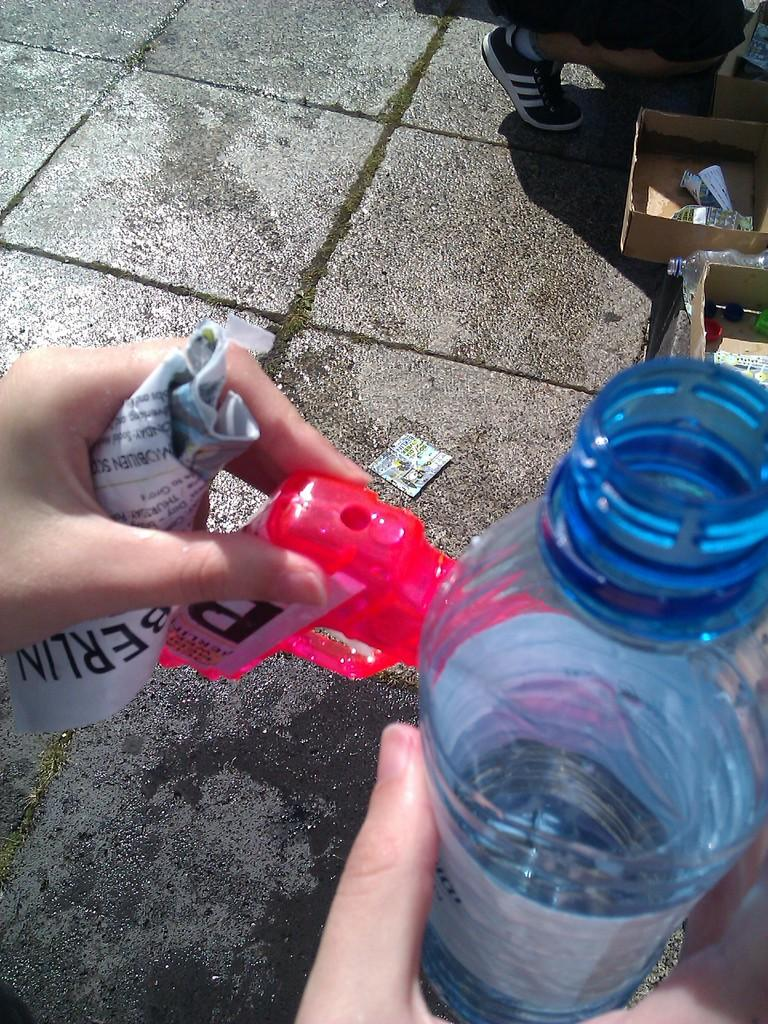What object is being held by someone in the image? The bottle is being held by someone in the image. What else can be seen in the image besides the bottle? There is a paper in the image. Can you describe the position or orientation of the paper? The facts provided do not give enough information to describe the position or orientation of the paper. What type of destruction can be seen happening to the bottle in the image? There is no destruction happening to the bottle in the image; it is being held by someone. What note is written on the paper in the image? The facts provided do not give enough information to determine if there is any writing on the paper or what it might say. 